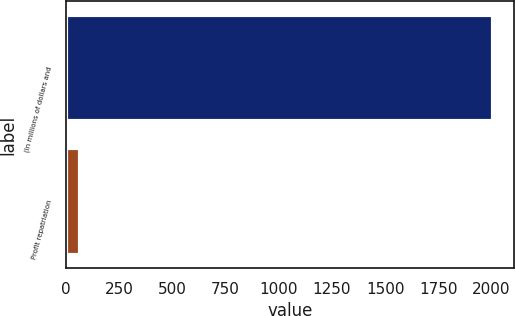Convert chart. <chart><loc_0><loc_0><loc_500><loc_500><bar_chart><fcel>(In millions of dollars and<fcel>Profit repatriation<nl><fcel>2007<fcel>67.8<nl></chart> 